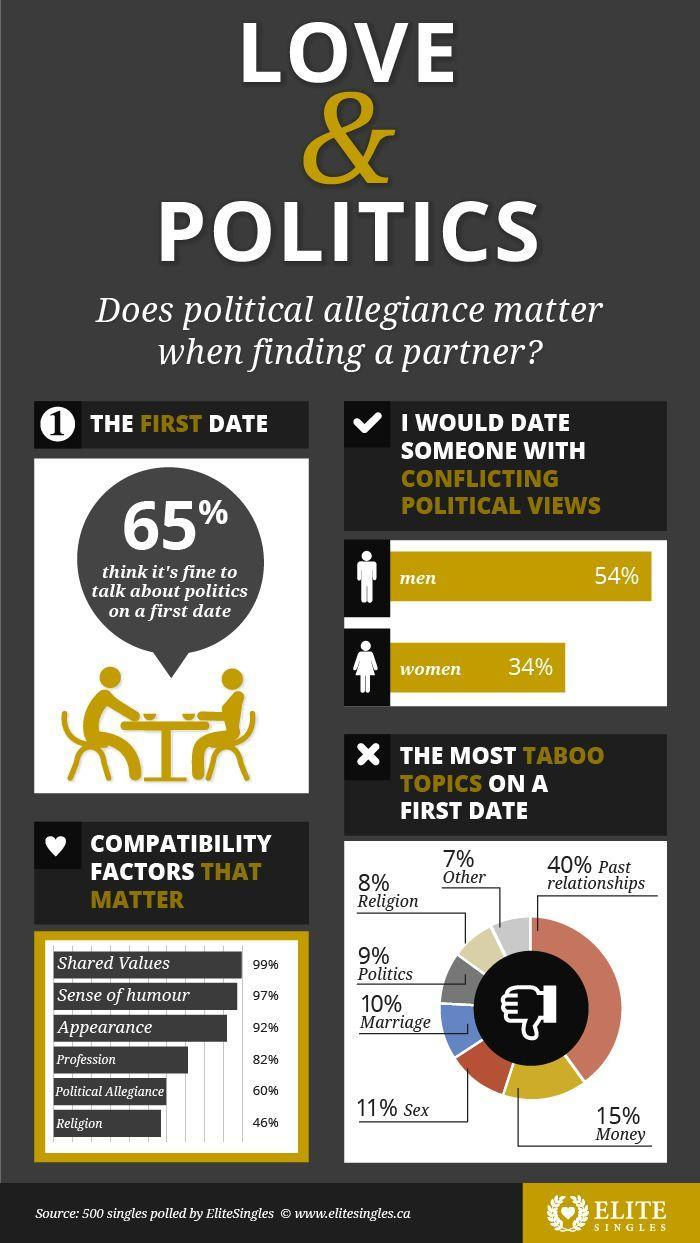What percentage of females is ready to meet a partner with a different political viewpoint?
Answer the question with a short phrase. 34% What is the inverse percentage of people who believe it's okay to talk about politics on the first date? 35 What is the second-highest compatibility factor that affects Love? Sense of humour What percentage of males is ready to meet a partner with a different political viewpoint? 54 What is the least no-no topic on the first date? Other What is the third-highest compatibility factor that affects Love? Appearance What is the most no-no topic on the first date? Past relationships What is the fourth-highest compatibility factor that affects Love? Profession 